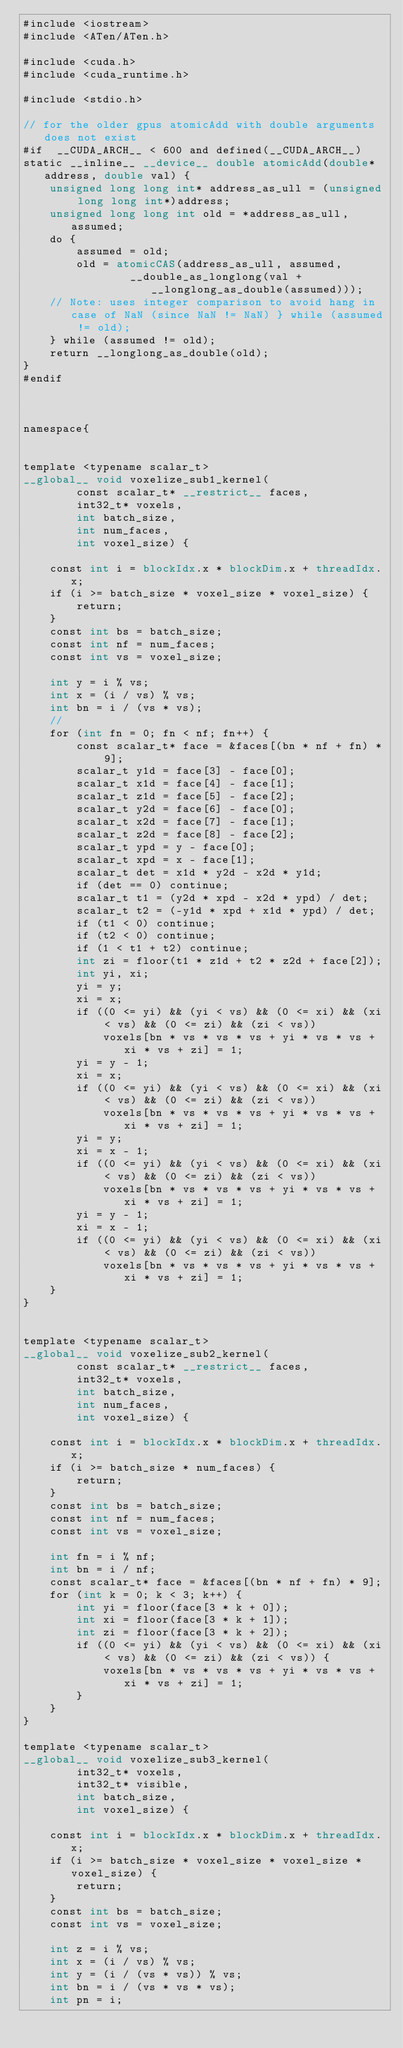Convert code to text. <code><loc_0><loc_0><loc_500><loc_500><_Cuda_>#include <iostream>
#include <ATen/ATen.h>

#include <cuda.h>
#include <cuda_runtime.h>

#include <stdio.h>

// for the older gpus atomicAdd with double arguments does not exist
#if  __CUDA_ARCH__ < 600 and defined(__CUDA_ARCH__)
static __inline__ __device__ double atomicAdd(double* address, double val) {
    unsigned long long int* address_as_ull = (unsigned long long int*)address;
    unsigned long long int old = *address_as_ull, assumed;
    do {
        assumed = old;
        old = atomicCAS(address_as_ull, assumed,
                __double_as_longlong(val + __longlong_as_double(assumed)));
    // Note: uses integer comparison to avoid hang in case of NaN (since NaN != NaN) } while (assumed != old);
    } while (assumed != old);
    return __longlong_as_double(old);
}
#endif



namespace{


template <typename scalar_t>
__global__ void voxelize_sub1_kernel(
        const scalar_t* __restrict__ faces,
        int32_t* voxels,
        int batch_size,
        int num_faces,
        int voxel_size) {

    const int i = blockIdx.x * blockDim.x + threadIdx.x;
    if (i >= batch_size * voxel_size * voxel_size) {
        return;
    }
    const int bs = batch_size;
    const int nf = num_faces;
    const int vs = voxel_size;

    int y = i % vs;
    int x = (i / vs) % vs;
    int bn = i / (vs * vs);
    //
    for (int fn = 0; fn < nf; fn++) {
        const scalar_t* face = &faces[(bn * nf + fn) * 9];
        scalar_t y1d = face[3] - face[0];
        scalar_t x1d = face[4] - face[1];
        scalar_t z1d = face[5] - face[2];
        scalar_t y2d = face[6] - face[0];
        scalar_t x2d = face[7] - face[1];
        scalar_t z2d = face[8] - face[2];
        scalar_t ypd = y - face[0];
        scalar_t xpd = x - face[1];
        scalar_t det = x1d * y2d - x2d * y1d;
        if (det == 0) continue;
        scalar_t t1 = (y2d * xpd - x2d * ypd) / det;
        scalar_t t2 = (-y1d * xpd + x1d * ypd) / det;
        if (t1 < 0) continue;
        if (t2 < 0) continue;
        if (1 < t1 + t2) continue;
        int zi = floor(t1 * z1d + t2 * z2d + face[2]);
        int yi, xi;
        yi = y;
        xi = x;
        if ((0 <= yi) && (yi < vs) && (0 <= xi) && (xi < vs) && (0 <= zi) && (zi < vs))
            voxels[bn * vs * vs * vs + yi * vs * vs + xi * vs + zi] = 1;
        yi = y - 1;
        xi = x;
        if ((0 <= yi) && (yi < vs) && (0 <= xi) && (xi < vs) && (0 <= zi) && (zi < vs))
            voxels[bn * vs * vs * vs + yi * vs * vs + xi * vs + zi] = 1;
        yi = y;
        xi = x - 1;
        if ((0 <= yi) && (yi < vs) && (0 <= xi) && (xi < vs) && (0 <= zi) && (zi < vs))
            voxels[bn * vs * vs * vs + yi * vs * vs + xi * vs + zi] = 1;
        yi = y - 1;
        xi = x - 1;
        if ((0 <= yi) && (yi < vs) && (0 <= xi) && (xi < vs) && (0 <= zi) && (zi < vs))
            voxels[bn * vs * vs * vs + yi * vs * vs + xi * vs + zi] = 1;
    }
}


template <typename scalar_t>
__global__ void voxelize_sub2_kernel(
        const scalar_t* __restrict__ faces,
        int32_t* voxels,
        int batch_size,
        int num_faces,
        int voxel_size) {

    const int i = blockIdx.x * blockDim.x + threadIdx.x;
    if (i >= batch_size * num_faces) {
        return;
    }
    const int bs = batch_size;
    const int nf = num_faces;
    const int vs = voxel_size;

    int fn = i % nf;
    int bn = i / nf;
    const scalar_t* face = &faces[(bn * nf + fn) * 9];
    for (int k = 0; k < 3; k++) {
        int yi = floor(face[3 * k + 0]);
        int xi = floor(face[3 * k + 1]);
        int zi = floor(face[3 * k + 2]);
        if ((0 <= yi) && (yi < vs) && (0 <= xi) && (xi < vs) && (0 <= zi) && (zi < vs)) {
            voxels[bn * vs * vs * vs + yi * vs * vs + xi * vs + zi] = 1;
        }
    }
}

template <typename scalar_t>
__global__ void voxelize_sub3_kernel(
        int32_t* voxels,
        int32_t* visible,
        int batch_size,
        int voxel_size) {

    const int i = blockIdx.x * blockDim.x + threadIdx.x;
    if (i >= batch_size * voxel_size * voxel_size * voxel_size) {
        return;
    }
    const int bs = batch_size;
    const int vs = voxel_size;

    int z = i % vs;
    int x = (i / vs) % vs;
    int y = (i / (vs * vs)) % vs;
    int bn = i / (vs * vs * vs);
    int pn = i;</code> 